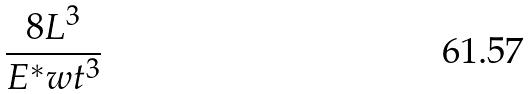<formula> <loc_0><loc_0><loc_500><loc_500>\frac { 8 L ^ { 3 } } { E ^ { * } w t ^ { 3 } }</formula> 